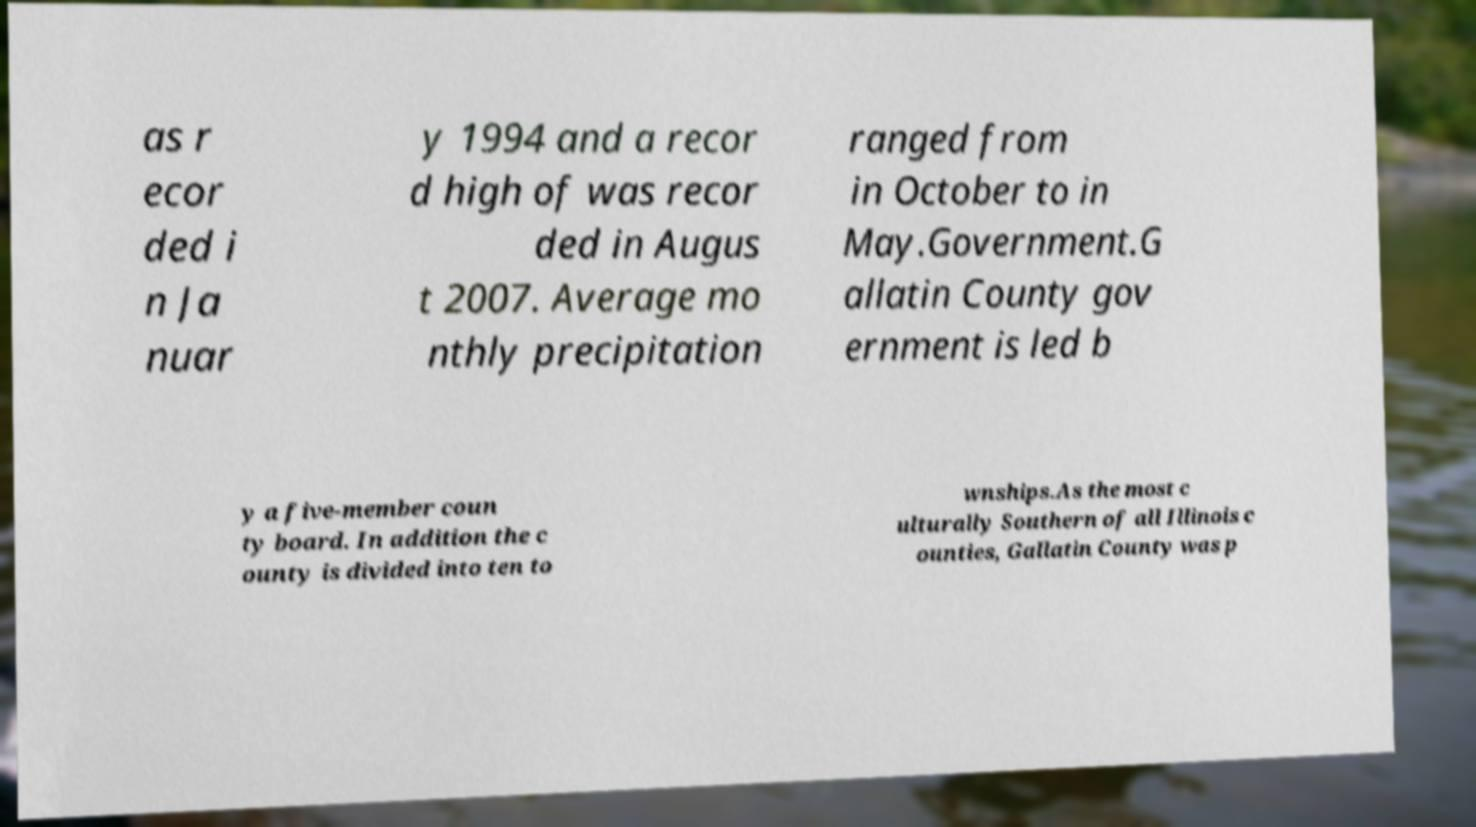Can you read and provide the text displayed in the image?This photo seems to have some interesting text. Can you extract and type it out for me? as r ecor ded i n Ja nuar y 1994 and a recor d high of was recor ded in Augus t 2007. Average mo nthly precipitation ranged from in October to in May.Government.G allatin County gov ernment is led b y a five-member coun ty board. In addition the c ounty is divided into ten to wnships.As the most c ulturally Southern of all Illinois c ounties, Gallatin County was p 